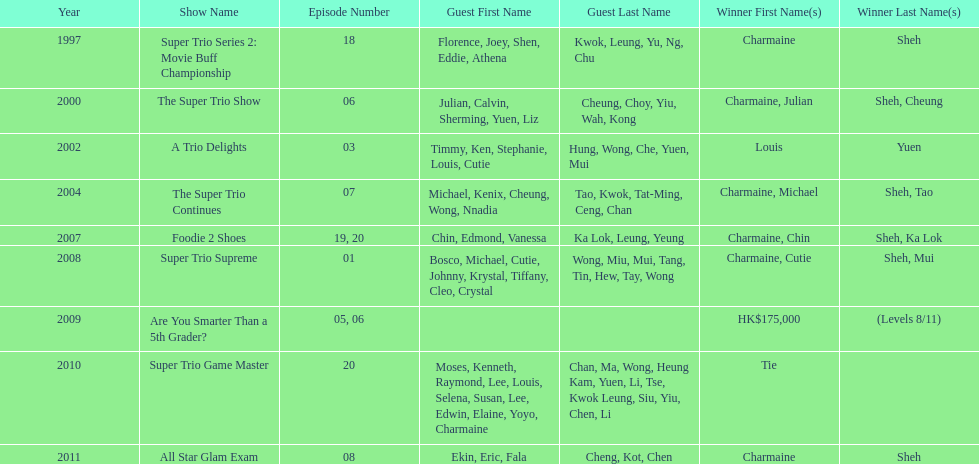How many consecutive trio shows did charmaine sheh do before being on another variety program? 34. 